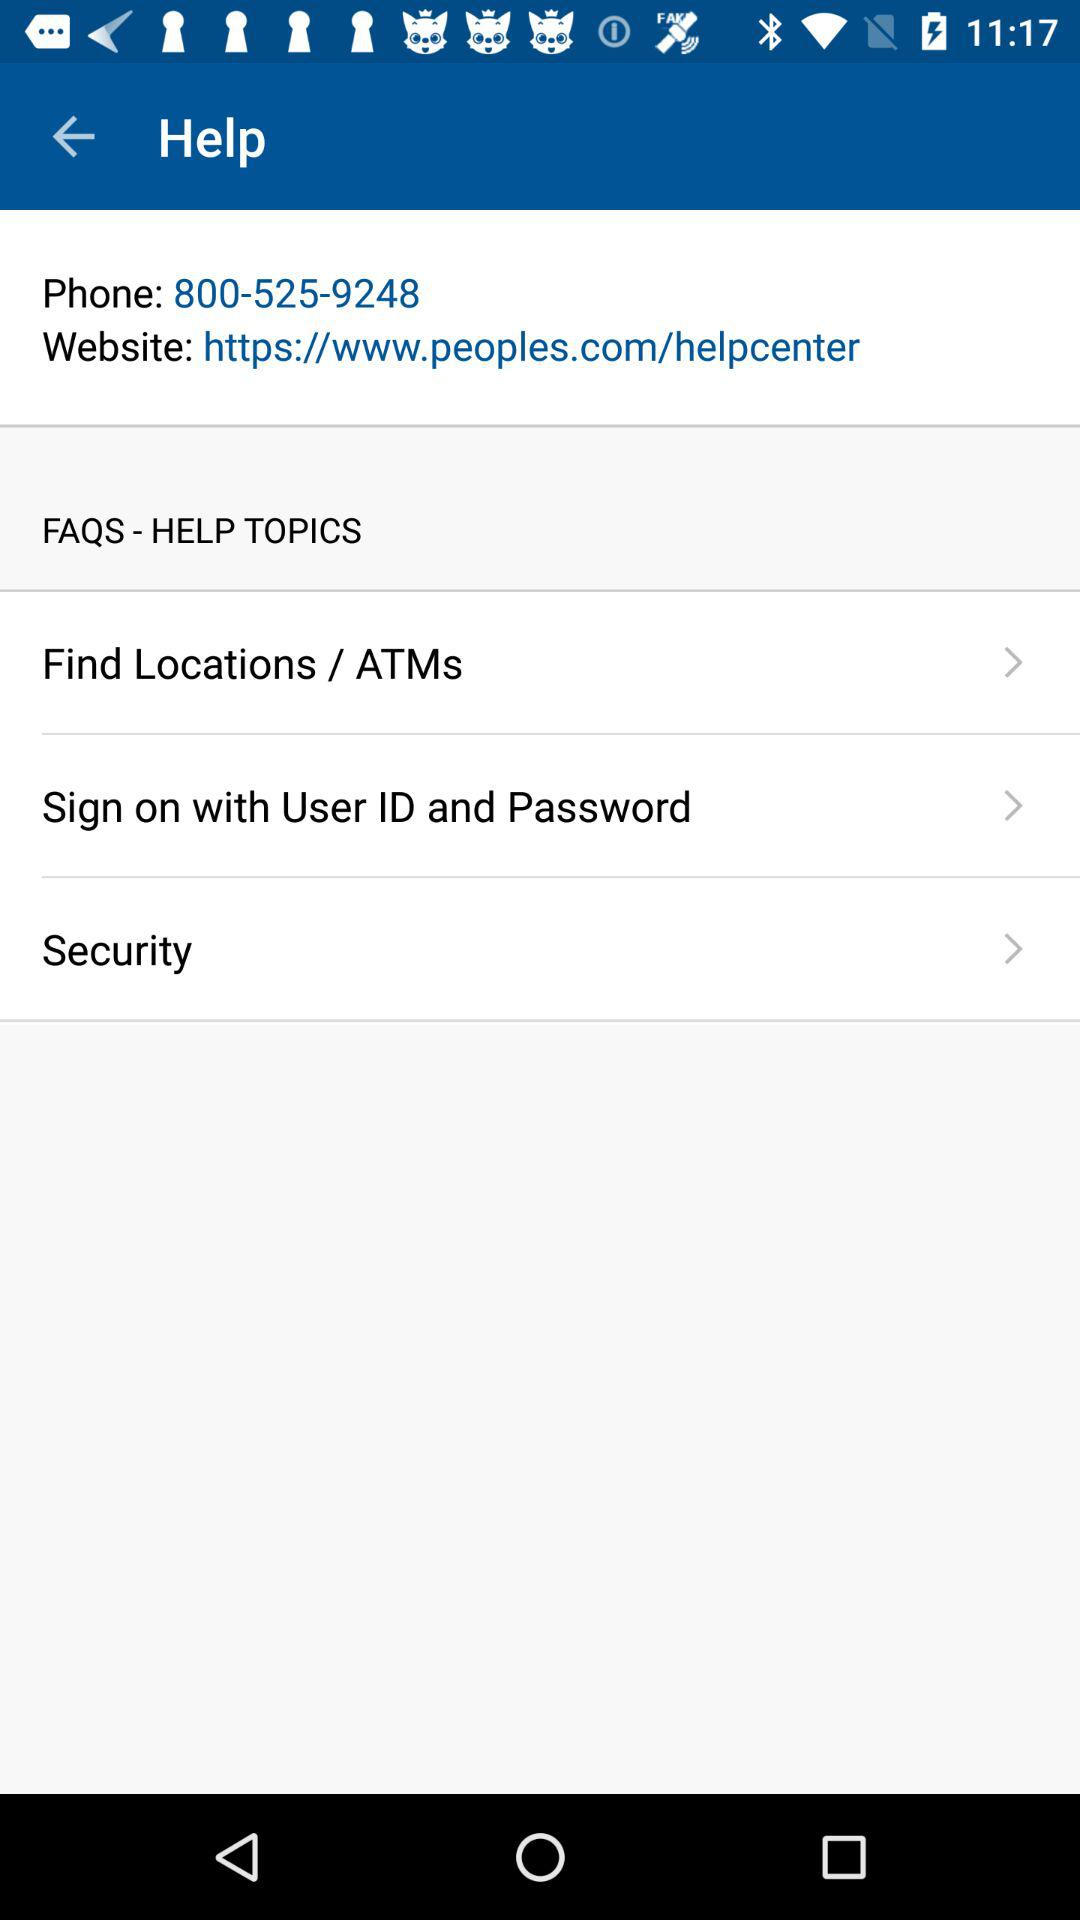What are the "FAQS - HELP TOPICS"? The "FAQS - HELP TOPICS" are "Find Locations / ATMs", "Sign on with User ID and Password" and "Security". 